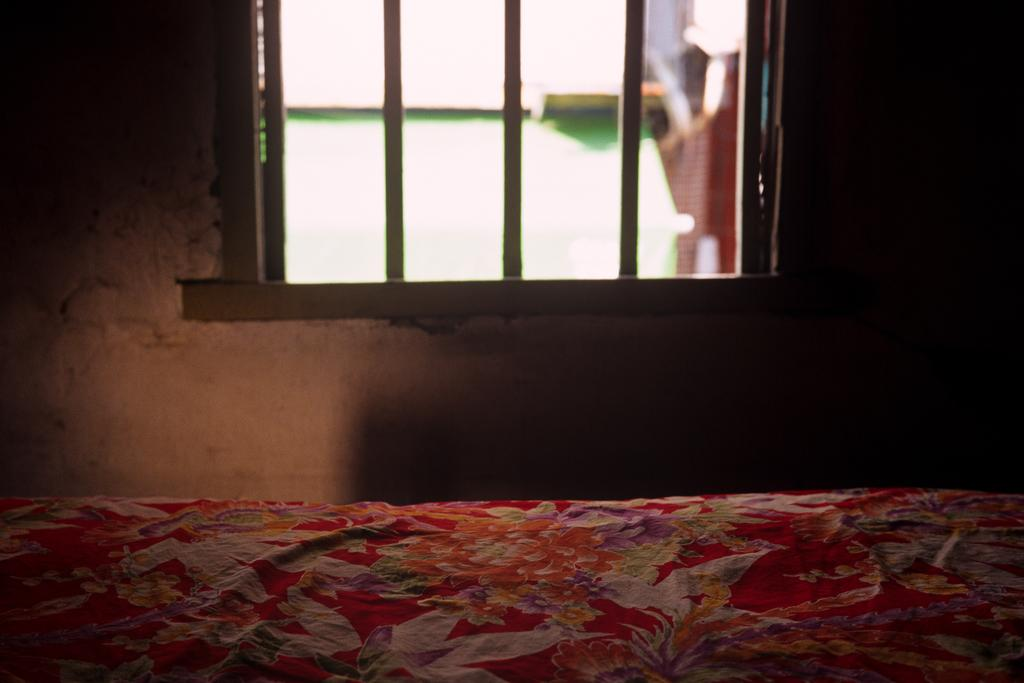What type of location is depicted in the image? The image shows an inside view of a house. What piece of furniture can be seen in the image? There is a bed in the image. Is there any source of natural light in the image? Yes, there is a window in the image. Can you describe the view through the window? The view through the window appears blurry. What type of locket is hanging from the bedpost in the image? There is no locket hanging from the bedpost in the image. What kind of toys can be seen scattered on the floor in the image? There are no toys visible on the floor in the image. 